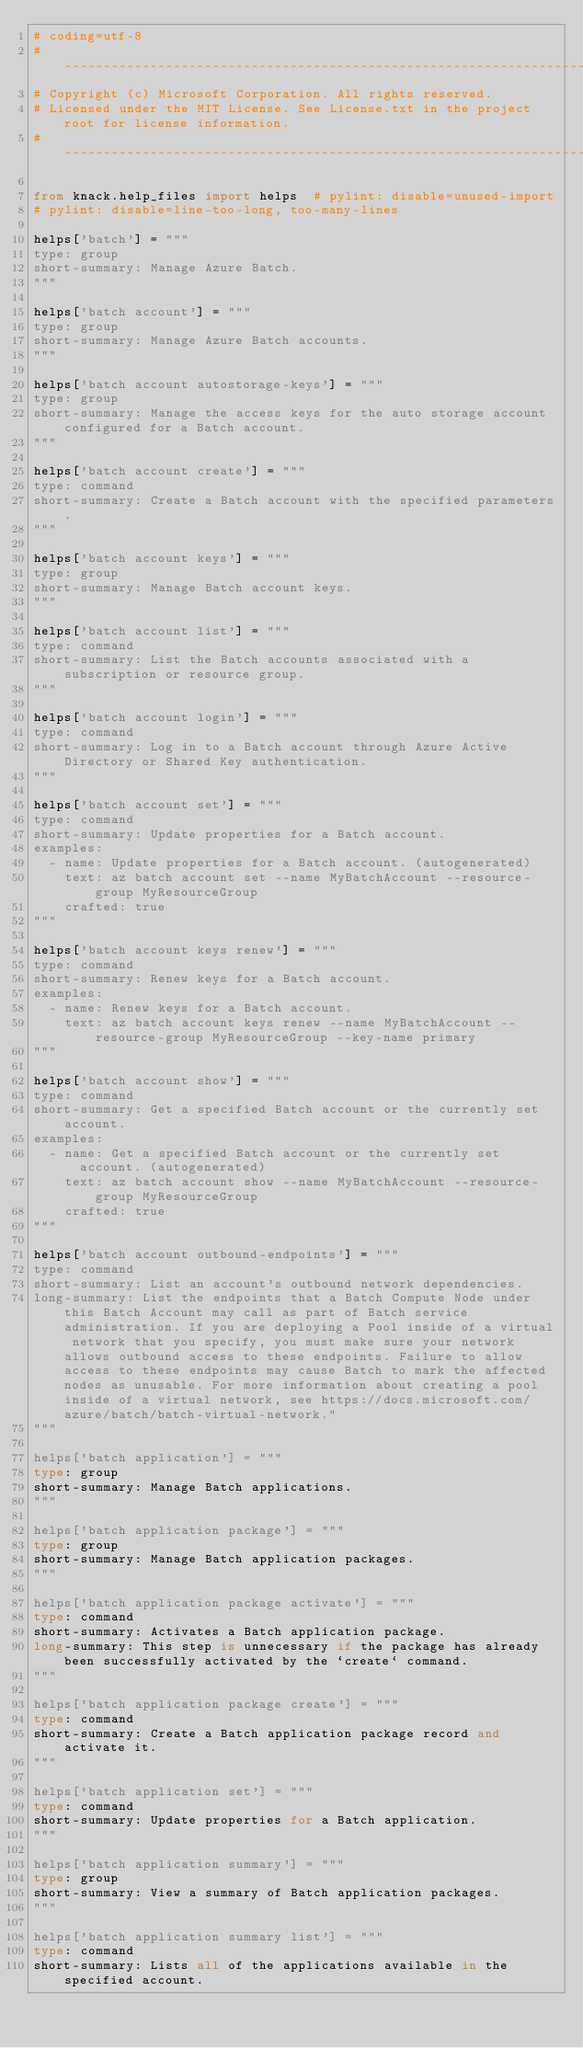<code> <loc_0><loc_0><loc_500><loc_500><_Python_># coding=utf-8
# --------------------------------------------------------------------------------------------
# Copyright (c) Microsoft Corporation. All rights reserved.
# Licensed under the MIT License. See License.txt in the project root for license information.
# --------------------------------------------------------------------------------------------

from knack.help_files import helps  # pylint: disable=unused-import
# pylint: disable=line-too-long, too-many-lines

helps['batch'] = """
type: group
short-summary: Manage Azure Batch.
"""

helps['batch account'] = """
type: group
short-summary: Manage Azure Batch accounts.
"""

helps['batch account autostorage-keys'] = """
type: group
short-summary: Manage the access keys for the auto storage account configured for a Batch account.
"""

helps['batch account create'] = """
type: command
short-summary: Create a Batch account with the specified parameters.
"""

helps['batch account keys'] = """
type: group
short-summary: Manage Batch account keys.
"""

helps['batch account list'] = """
type: command
short-summary: List the Batch accounts associated with a subscription or resource group.
"""

helps['batch account login'] = """
type: command
short-summary: Log in to a Batch account through Azure Active Directory or Shared Key authentication.
"""

helps['batch account set'] = """
type: command
short-summary: Update properties for a Batch account.
examples:
  - name: Update properties for a Batch account. (autogenerated)
    text: az batch account set --name MyBatchAccount --resource-group MyResourceGroup
    crafted: true
"""

helps['batch account keys renew'] = """
type: command
short-summary: Renew keys for a Batch account.
examples:
  - name: Renew keys for a Batch account.
    text: az batch account keys renew --name MyBatchAccount --resource-group MyResourceGroup --key-name primary
"""

helps['batch account show'] = """
type: command
short-summary: Get a specified Batch account or the currently set account.
examples:
  - name: Get a specified Batch account or the currently set account. (autogenerated)
    text: az batch account show --name MyBatchAccount --resource-group MyResourceGroup
    crafted: true
"""

helps['batch account outbound-endpoints'] = """
type: command
short-summary: List an account's outbound network dependencies.
long-summary: List the endpoints that a Batch Compute Node under this Batch Account may call as part of Batch service administration. If you are deploying a Pool inside of a virtual network that you specify, you must make sure your network allows outbound access to these endpoints. Failure to allow access to these endpoints may cause Batch to mark the affected nodes as unusable. For more information about creating a pool inside of a virtual network, see https://docs.microsoft.com/azure/batch/batch-virtual-network."
"""

helps['batch application'] = """
type: group
short-summary: Manage Batch applications.
"""

helps['batch application package'] = """
type: group
short-summary: Manage Batch application packages.
"""

helps['batch application package activate'] = """
type: command
short-summary: Activates a Batch application package.
long-summary: This step is unnecessary if the package has already been successfully activated by the `create` command.
"""

helps['batch application package create'] = """
type: command
short-summary: Create a Batch application package record and activate it.
"""

helps['batch application set'] = """
type: command
short-summary: Update properties for a Batch application.
"""

helps['batch application summary'] = """
type: group
short-summary: View a summary of Batch application packages.
"""

helps['batch application summary list'] = """
type: command
short-summary: Lists all of the applications available in the specified account.</code> 